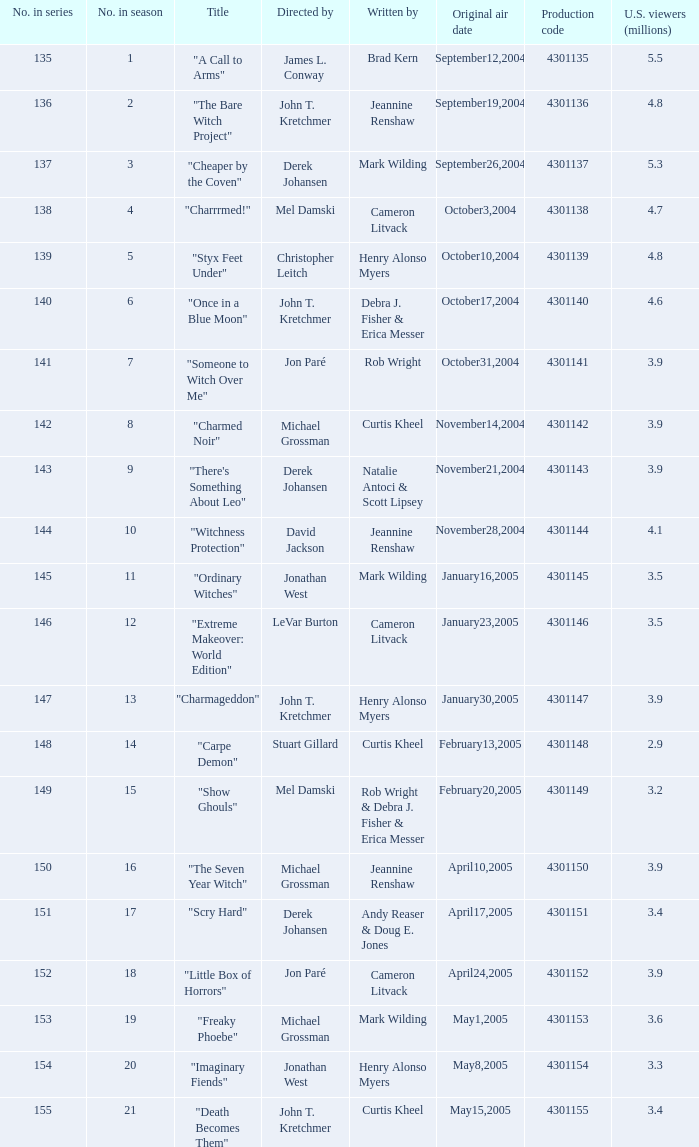In the series, what is the number when the writers are rob wright, debra j. fisher, and erica messer? 149.0. 